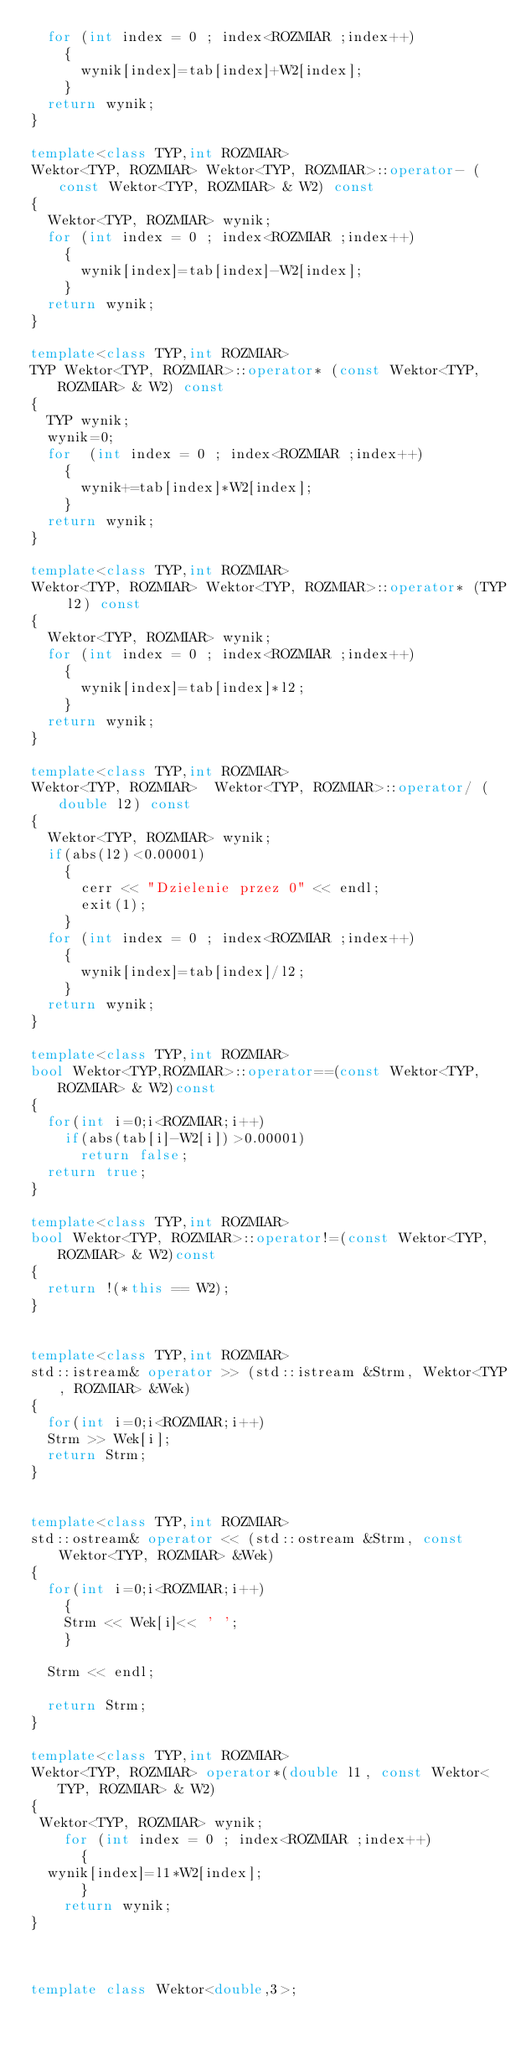<code> <loc_0><loc_0><loc_500><loc_500><_C++_>  for (int index = 0 ; index<ROZMIAR ;index++)
    {
      wynik[index]=tab[index]+W2[index];
    }
  return wynik;
}

template<class TYP,int ROZMIAR>
Wektor<TYP, ROZMIAR> Wektor<TYP, ROZMIAR>::operator- (const Wektor<TYP, ROZMIAR> & W2) const
{
  Wektor<TYP, ROZMIAR> wynik;
  for (int index = 0 ; index<ROZMIAR ;index++)
    {
      wynik[index]=tab[index]-W2[index];
    }
  return wynik;
}

template<class TYP,int ROZMIAR>
TYP Wektor<TYP, ROZMIAR>::operator* (const Wektor<TYP, ROZMIAR> & W2) const
{
  TYP wynik;
  wynik=0;
  for  (int index = 0 ; index<ROZMIAR ;index++)
    {
      wynik+=tab[index]*W2[index];
    }
  return wynik;
}

template<class TYP,int ROZMIAR>
Wektor<TYP, ROZMIAR> Wektor<TYP, ROZMIAR>::operator* (TYP l2) const
{
  Wektor<TYP, ROZMIAR> wynik;
  for (int index = 0 ; index<ROZMIAR ;index++)
    {
      wynik[index]=tab[index]*l2;
    }
  return wynik;
}

template<class TYP,int ROZMIAR>
Wektor<TYP, ROZMIAR>  Wektor<TYP, ROZMIAR>::operator/ (double l2) const
{
  Wektor<TYP, ROZMIAR> wynik;
  if(abs(l2)<0.00001)
    {
      cerr << "Dzielenie przez 0" << endl;
      exit(1);
    }
  for (int index = 0 ; index<ROZMIAR ;index++)
    {
      wynik[index]=tab[index]/l2;
    }
  return wynik;
}

template<class TYP,int ROZMIAR>
bool Wektor<TYP,ROZMIAR>::operator==(const Wektor<TYP,ROZMIAR> & W2)const
{
  for(int i=0;i<ROZMIAR;i++)
    if(abs(tab[i]-W2[i])>0.00001) 
      return false;
  return true;
}

template<class TYP,int ROZMIAR>
bool Wektor<TYP, ROZMIAR>::operator!=(const Wektor<TYP, ROZMIAR> & W2)const
{
  return !(*this == W2);
}


template<class TYP,int ROZMIAR>
std::istream& operator >> (std::istream &Strm, Wektor<TYP, ROZMIAR> &Wek)
{
  for(int i=0;i<ROZMIAR;i++)
  Strm >> Wek[i];
  return Strm; 
}


template<class TYP,int ROZMIAR>
std::ostream& operator << (std::ostream &Strm, const Wektor<TYP, ROZMIAR> &Wek)
{
  for(int i=0;i<ROZMIAR;i++)
    {
    Strm << Wek[i]<< ' ';
    }

  Strm << endl;
    
  return Strm;
}

template<class TYP,int ROZMIAR>
Wektor<TYP, ROZMIAR> operator*(double l1, const Wektor<TYP, ROZMIAR> & W2)
{
 Wektor<TYP, ROZMIAR> wynik;
    for (int index = 0 ; index<ROZMIAR ;index++)
      {
	wynik[index]=l1*W2[index];
      }
    return wynik;
}



template class Wektor<double,3>;</code> 